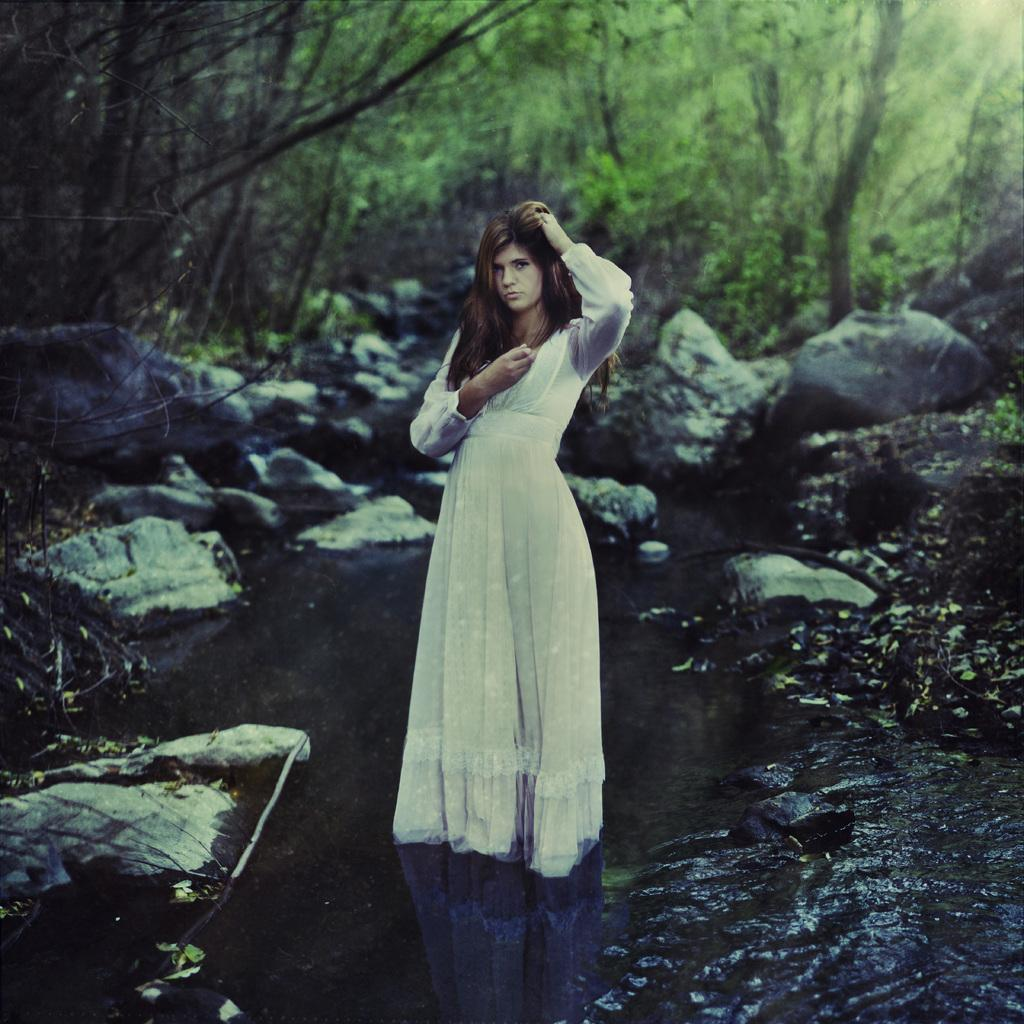Who is present in the image? There is a woman in the image. What is the woman doing in the image? The woman is standing in the image. What is the woman wearing in the image? The woman is wearing a white dress in the image. What type of environment is depicted in the image? There is water, stones, grass, and trees visible in the image. What type of flower is the woman holding in the image? There is no flower present in the image; the woman is not holding anything. 